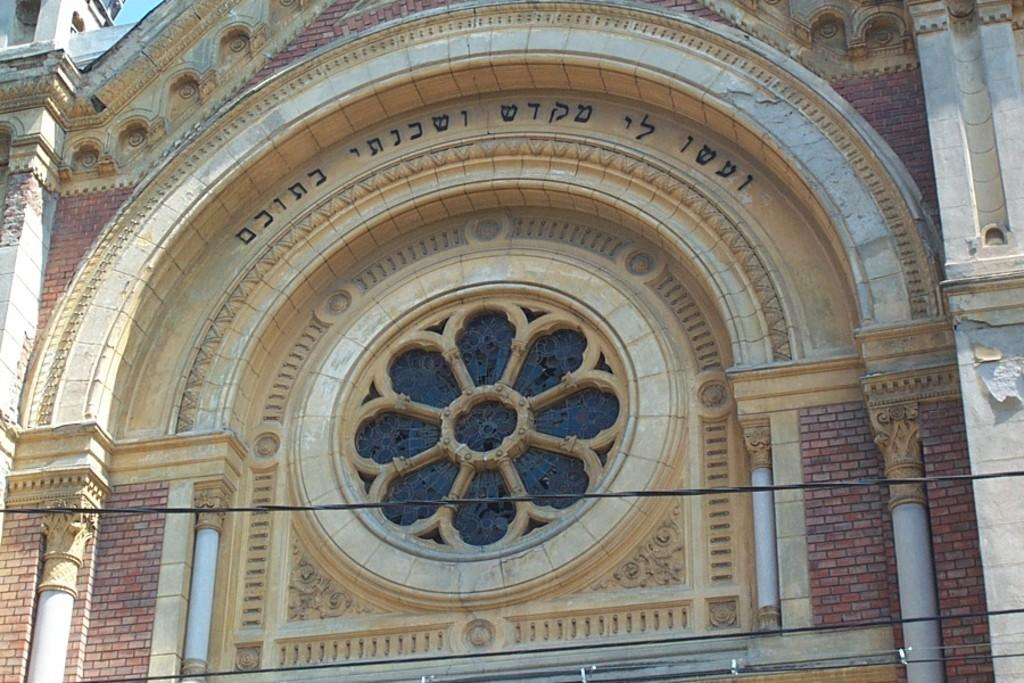What type of structure is present in the image? There is a building in the image. What architectural feature can be seen on the building? The building has pillars. What type of decoration is present on the building? There are sculptures on the wall of the building. What type of street is visible in the image? There is no street visible in the image; it only features a building with pillars and sculptures. How does the temper of the building change throughout the day in the image? The temper of the building cannot be determined from the image, as it does not provide information about the building's temperature or any changes in it. 